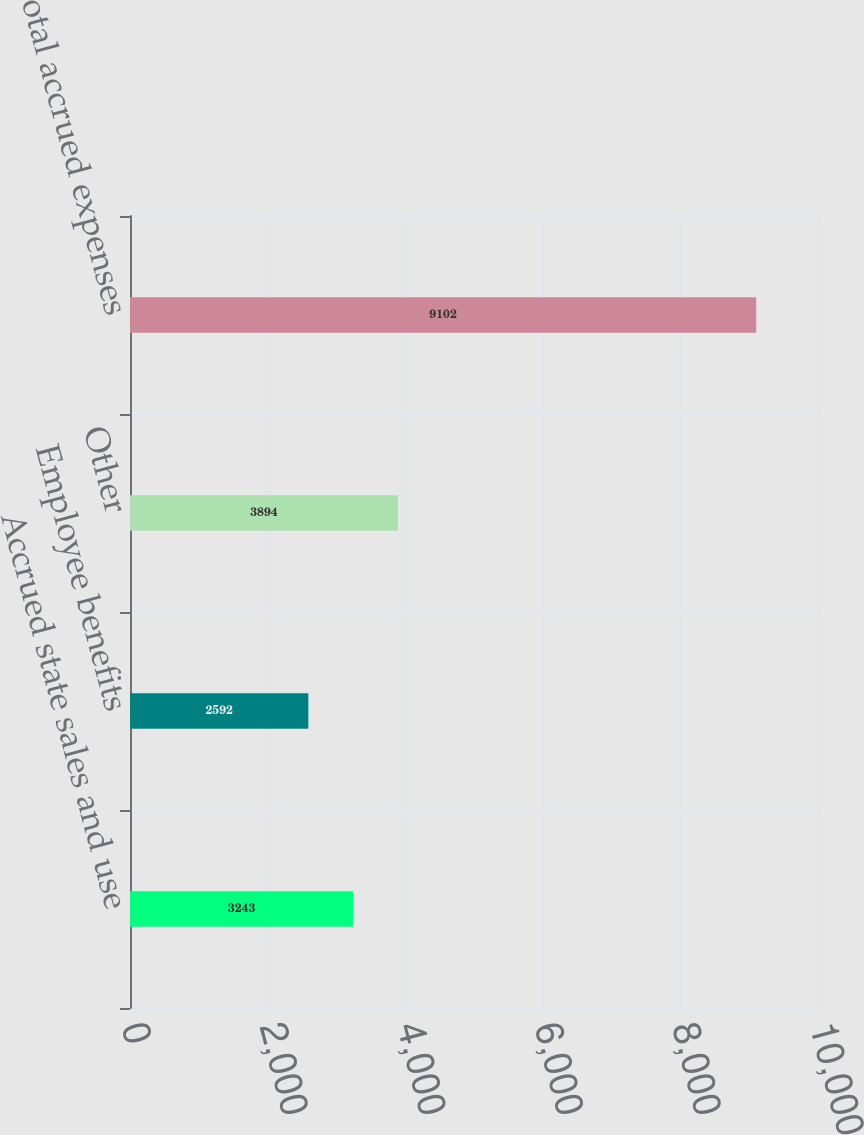<chart> <loc_0><loc_0><loc_500><loc_500><bar_chart><fcel>Accrued state sales and use<fcel>Employee benefits<fcel>Other<fcel>Total accrued expenses<nl><fcel>3243<fcel>2592<fcel>3894<fcel>9102<nl></chart> 